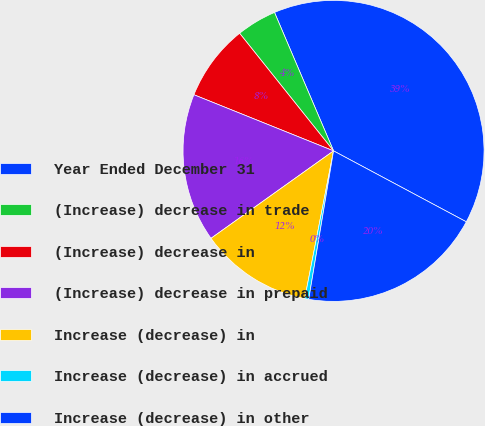Convert chart. <chart><loc_0><loc_0><loc_500><loc_500><pie_chart><fcel>Year Ended December 31<fcel>(Increase) decrease in trade<fcel>(Increase) decrease in<fcel>(Increase) decrease in prepaid<fcel>Increase (decrease) in<fcel>Increase (decrease) in accrued<fcel>Increase (decrease) in other<nl><fcel>39.23%<fcel>4.31%<fcel>8.19%<fcel>15.95%<fcel>12.07%<fcel>0.43%<fcel>19.83%<nl></chart> 